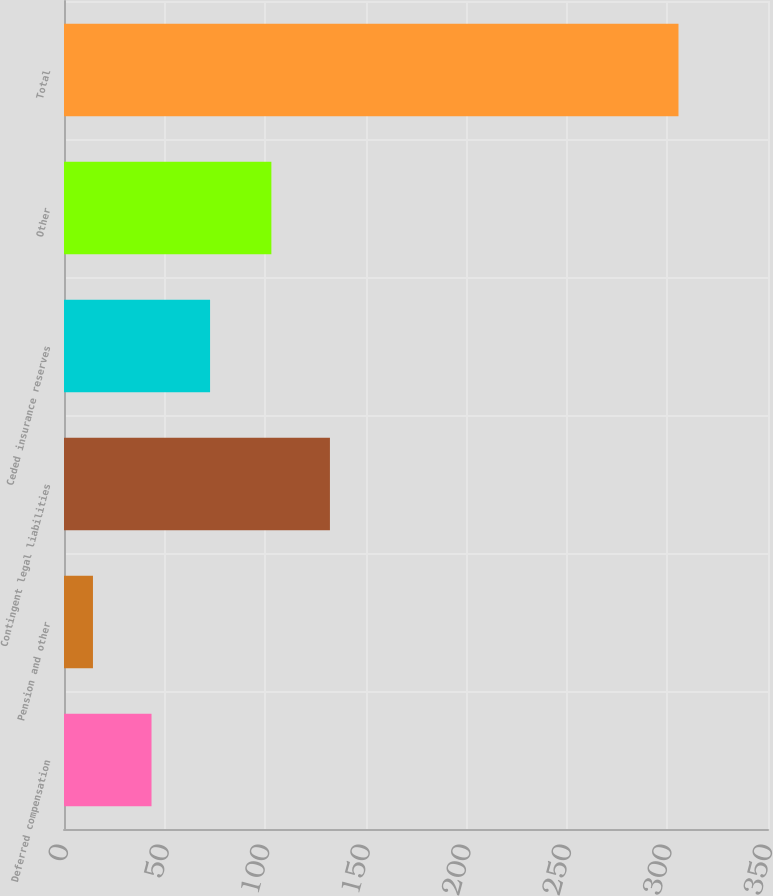Convert chart. <chart><loc_0><loc_0><loc_500><loc_500><bar_chart><fcel>Deferred compensation<fcel>Pension and other<fcel>Contingent legal liabilities<fcel>Ceded insurance reserves<fcel>Other<fcel>Total<nl><fcel>43.51<fcel>14.4<fcel>132.21<fcel>72.62<fcel>103.1<fcel>305.5<nl></chart> 